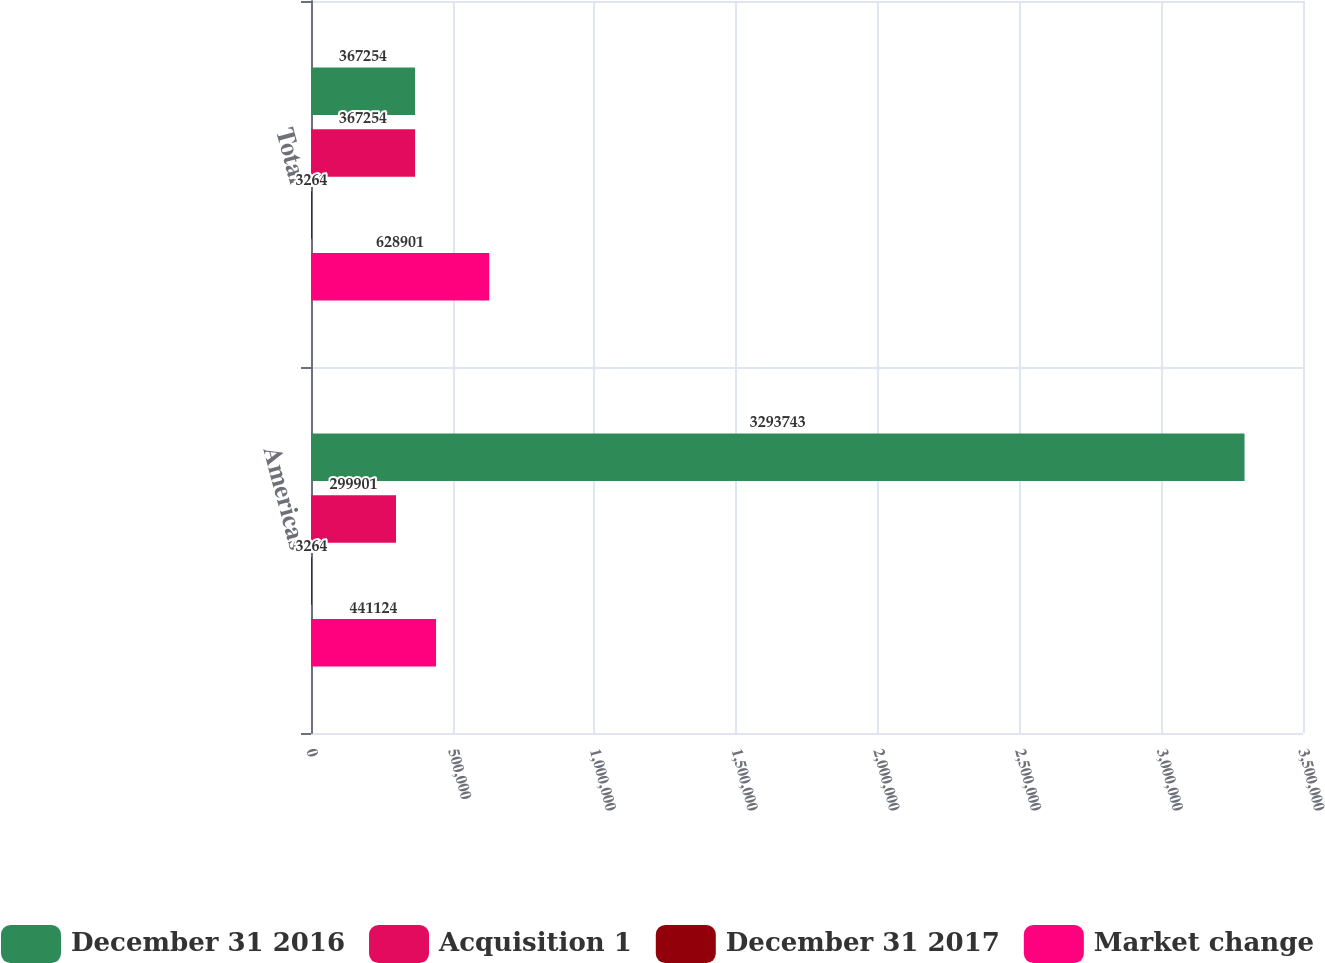Convert chart. <chart><loc_0><loc_0><loc_500><loc_500><stacked_bar_chart><ecel><fcel>Americas<fcel>Total<nl><fcel>December 31 2016<fcel>3.29374e+06<fcel>367254<nl><fcel>Acquisition 1<fcel>299901<fcel>367254<nl><fcel>December 31 2017<fcel>3264<fcel>3264<nl><fcel>Market change<fcel>441124<fcel>628901<nl></chart> 